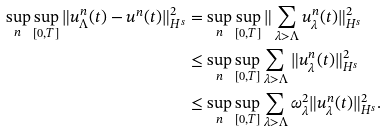<formula> <loc_0><loc_0><loc_500><loc_500>\sup _ { n } \sup _ { [ 0 , T ] } \| u _ { \Lambda } ^ { n } ( t ) - u ^ { n } ( t ) \| ^ { 2 } _ { H ^ { s } } & = \sup _ { n } \sup _ { [ 0 , T ] } \| \sum _ { \lambda > \Lambda } u ^ { n } _ { \lambda } ( t ) \| _ { H ^ { s } } ^ { 2 } \\ & \leq \sup _ { n } \sup _ { [ 0 , T ] } \sum _ { \lambda > \Lambda } \| u _ { \lambda } ^ { n } ( t ) \| _ { H ^ { s } } ^ { 2 } \\ & \leq \sup _ { n } \sup _ { [ 0 , T ] } \sum _ { \lambda > \Lambda } \omega _ { \lambda } ^ { 2 } \| u _ { \lambda } ^ { n } ( t ) \| ^ { 2 } _ { H ^ { s } } .</formula> 